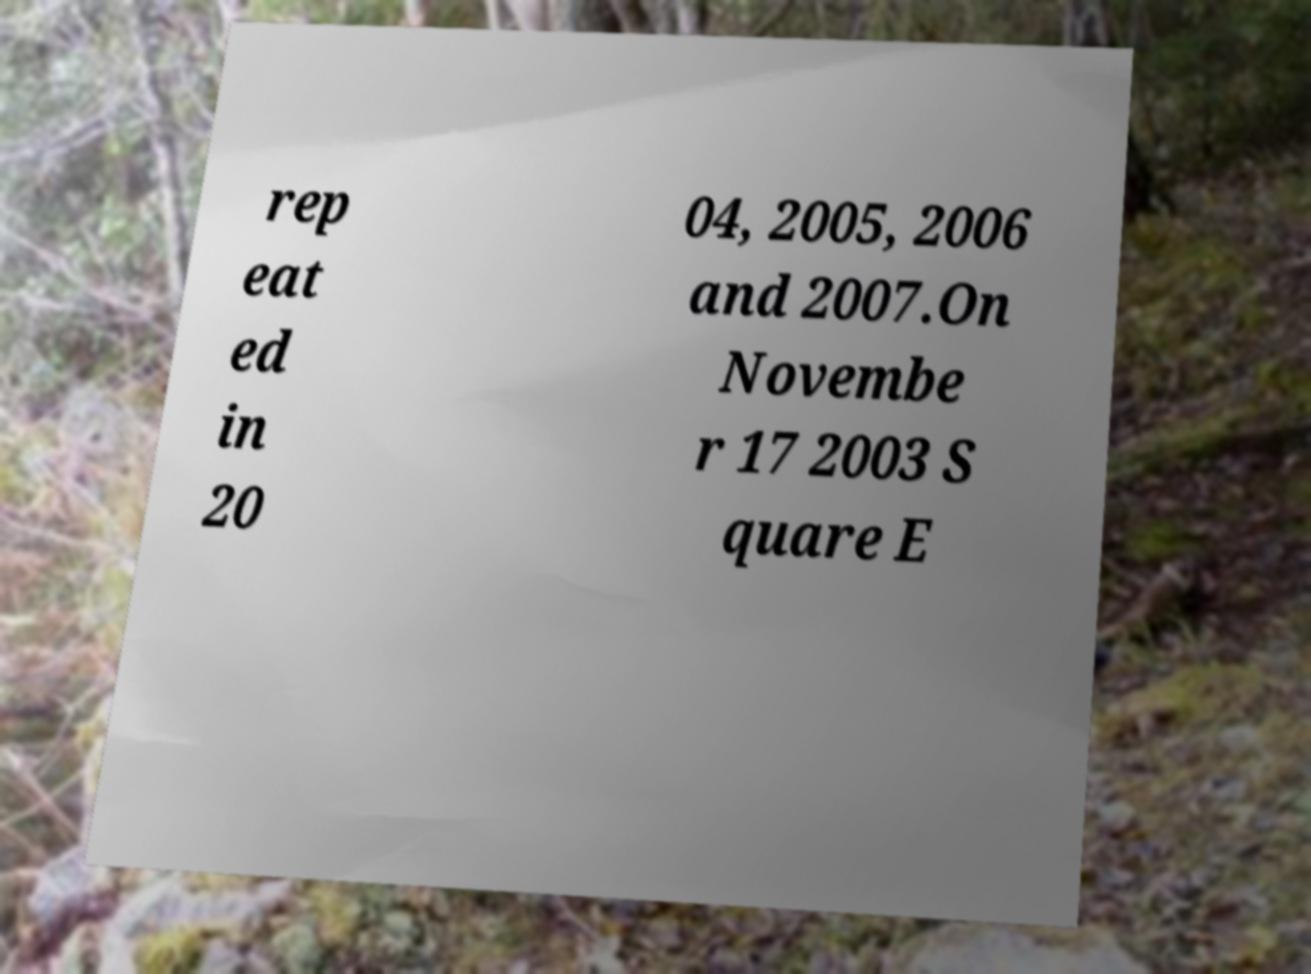There's text embedded in this image that I need extracted. Can you transcribe it verbatim? rep eat ed in 20 04, 2005, 2006 and 2007.On Novembe r 17 2003 S quare E 